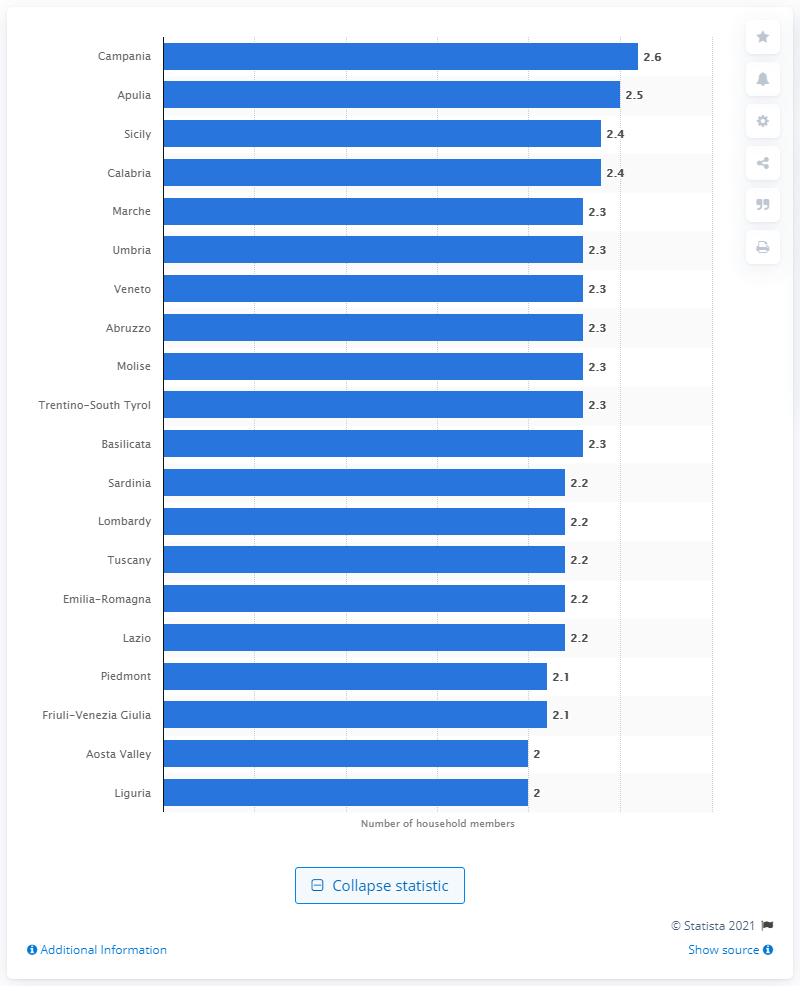Point out several critical features in this image. In 2019, the average size of households in Campania was 2.6 people. According to data, the average size of households in Sicily and Calabria is 2.4 people. 